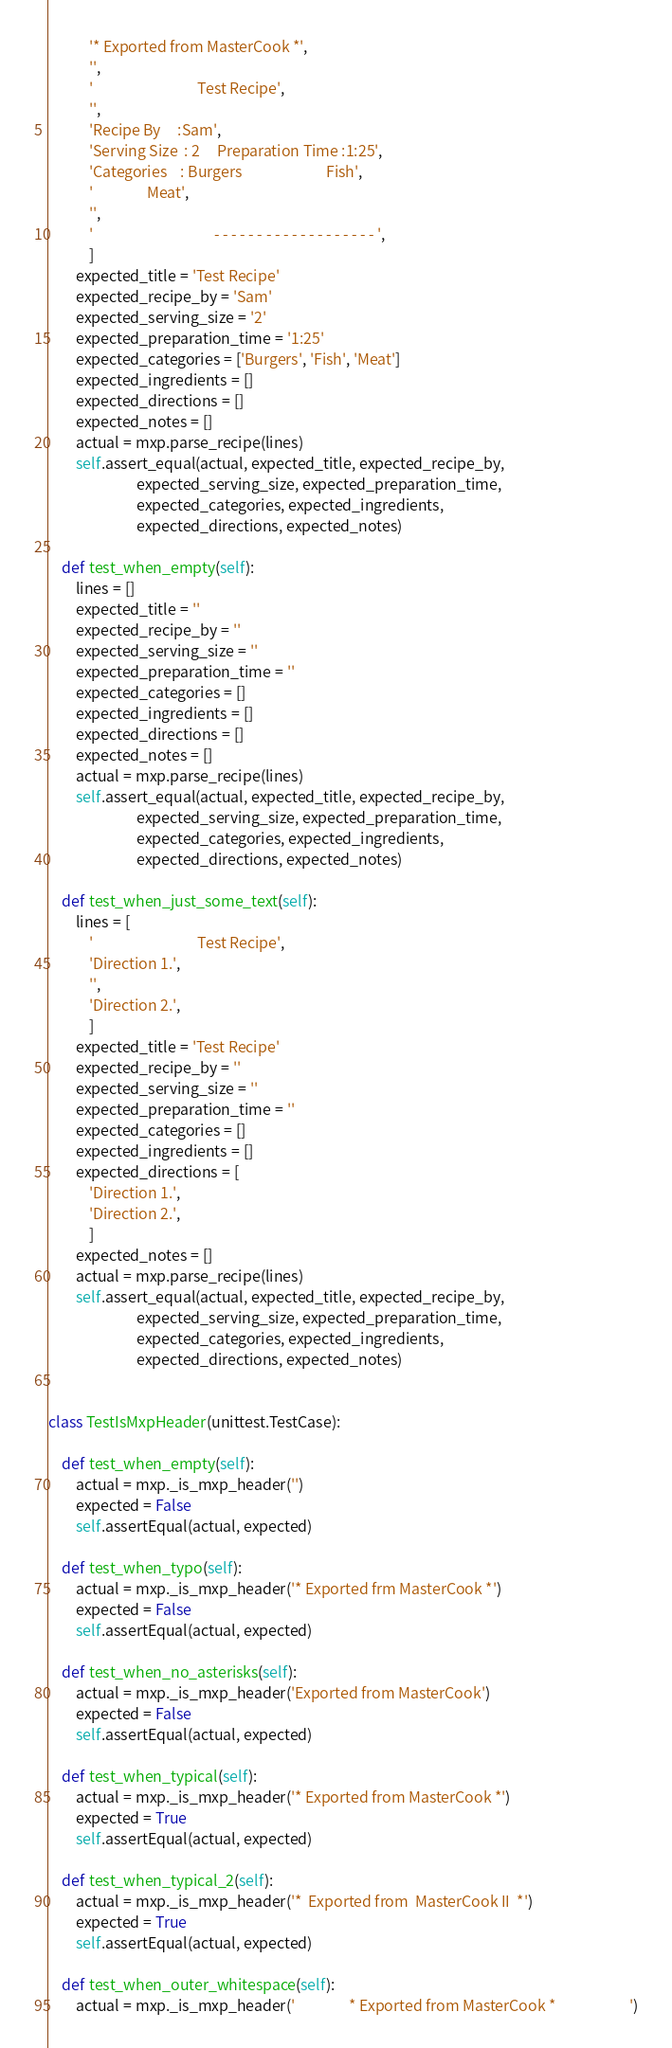Convert code to text. <code><loc_0><loc_0><loc_500><loc_500><_Python_>            '* Exported from MasterCook *',
            '',
            '                               Test Recipe',
            '',
            'Recipe By     :Sam',
            'Serving Size  : 2     Preparation Time :1:25',
            'Categories    : Burgers                         Fish',
            '                Meat',
            '',
            '                                    - - - - - - - - - - - - - - - - - - - ',
            ]
        expected_title = 'Test Recipe'
        expected_recipe_by = 'Sam'
        expected_serving_size = '2'
        expected_preparation_time = '1:25'
        expected_categories = ['Burgers', 'Fish', 'Meat']
        expected_ingredients = []
        expected_directions = []
        expected_notes = []
        actual = mxp.parse_recipe(lines)
        self.assert_equal(actual, expected_title, expected_recipe_by,
                          expected_serving_size, expected_preparation_time,
                          expected_categories, expected_ingredients,
                          expected_directions, expected_notes)
    
    def test_when_empty(self):
        lines = []
        expected_title = ''
        expected_recipe_by = ''
        expected_serving_size = ''
        expected_preparation_time = ''
        expected_categories = []
        expected_ingredients = []
        expected_directions = []
        expected_notes = []
        actual = mxp.parse_recipe(lines)
        self.assert_equal(actual, expected_title, expected_recipe_by,
                          expected_serving_size, expected_preparation_time,
                          expected_categories, expected_ingredients,
                          expected_directions, expected_notes)

    def test_when_just_some_text(self):
        lines = [
            '                               Test Recipe',
            'Direction 1.',
            '',
            'Direction 2.',
            ]
        expected_title = 'Test Recipe'
        expected_recipe_by = ''
        expected_serving_size = ''
        expected_preparation_time = ''
        expected_categories = []
        expected_ingredients = []
        expected_directions = [
            'Direction 1.',
            'Direction 2.',
            ]
        expected_notes = []
        actual = mxp.parse_recipe(lines)
        self.assert_equal(actual, expected_title, expected_recipe_by,
                          expected_serving_size, expected_preparation_time,
                          expected_categories, expected_ingredients,
                          expected_directions, expected_notes)


class TestIsMxpHeader(unittest.TestCase):

    def test_when_empty(self):
        actual = mxp._is_mxp_header('')
        expected = False
        self.assertEqual(actual, expected)

    def test_when_typo(self):
        actual = mxp._is_mxp_header('* Exported frm MasterCook *')
        expected = False
        self.assertEqual(actual, expected)

    def test_when_no_asterisks(self):
        actual = mxp._is_mxp_header('Exported from MasterCook')
        expected = False
        self.assertEqual(actual, expected)

    def test_when_typical(self):
        actual = mxp._is_mxp_header('* Exported from MasterCook *')
        expected = True
        self.assertEqual(actual, expected)

    def test_when_typical_2(self):
        actual = mxp._is_mxp_header('*  Exported from  MasterCook II  *')
        expected = True
        self.assertEqual(actual, expected)

    def test_when_outer_whitespace(self):
        actual = mxp._is_mxp_header('                * Exported from MasterCook *                      ')</code> 